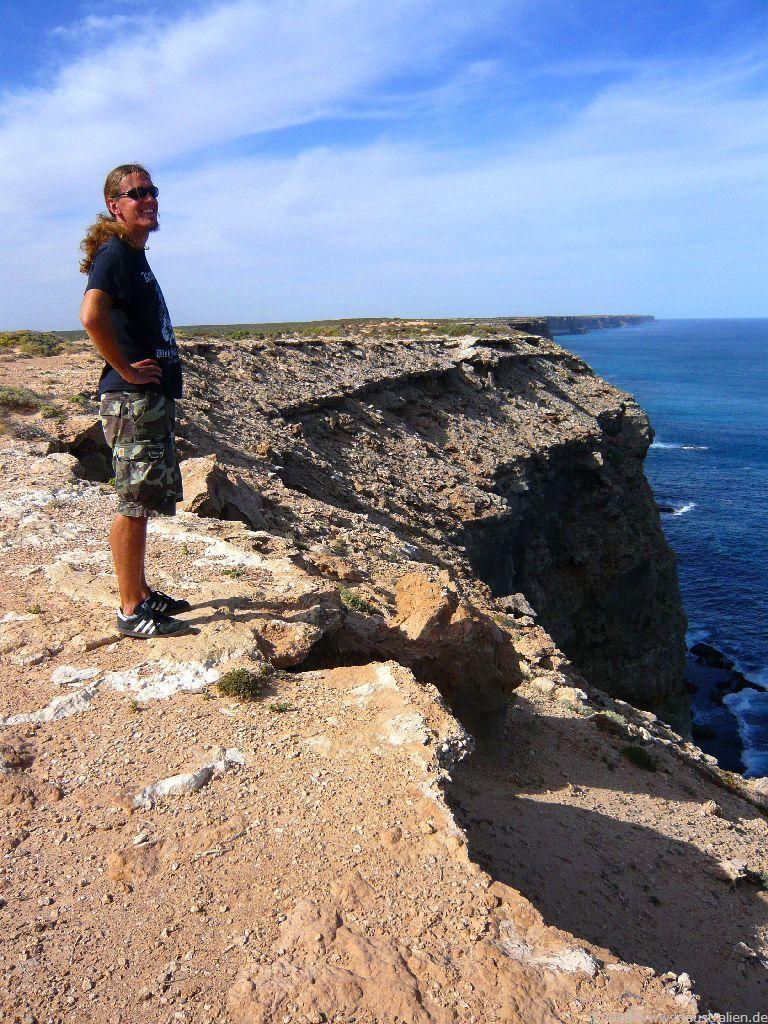What is the person in the image doing? The person is standing on the seashore. What other body of water is visible in the image? There is a river on the right side of the image. What can be seen in the background of the image? The sky is visible in the background of the image. What type of coat is the person wearing in the image? There is no coat visible in the image, as the person is standing on the seashore and not wearing any outerwear. 